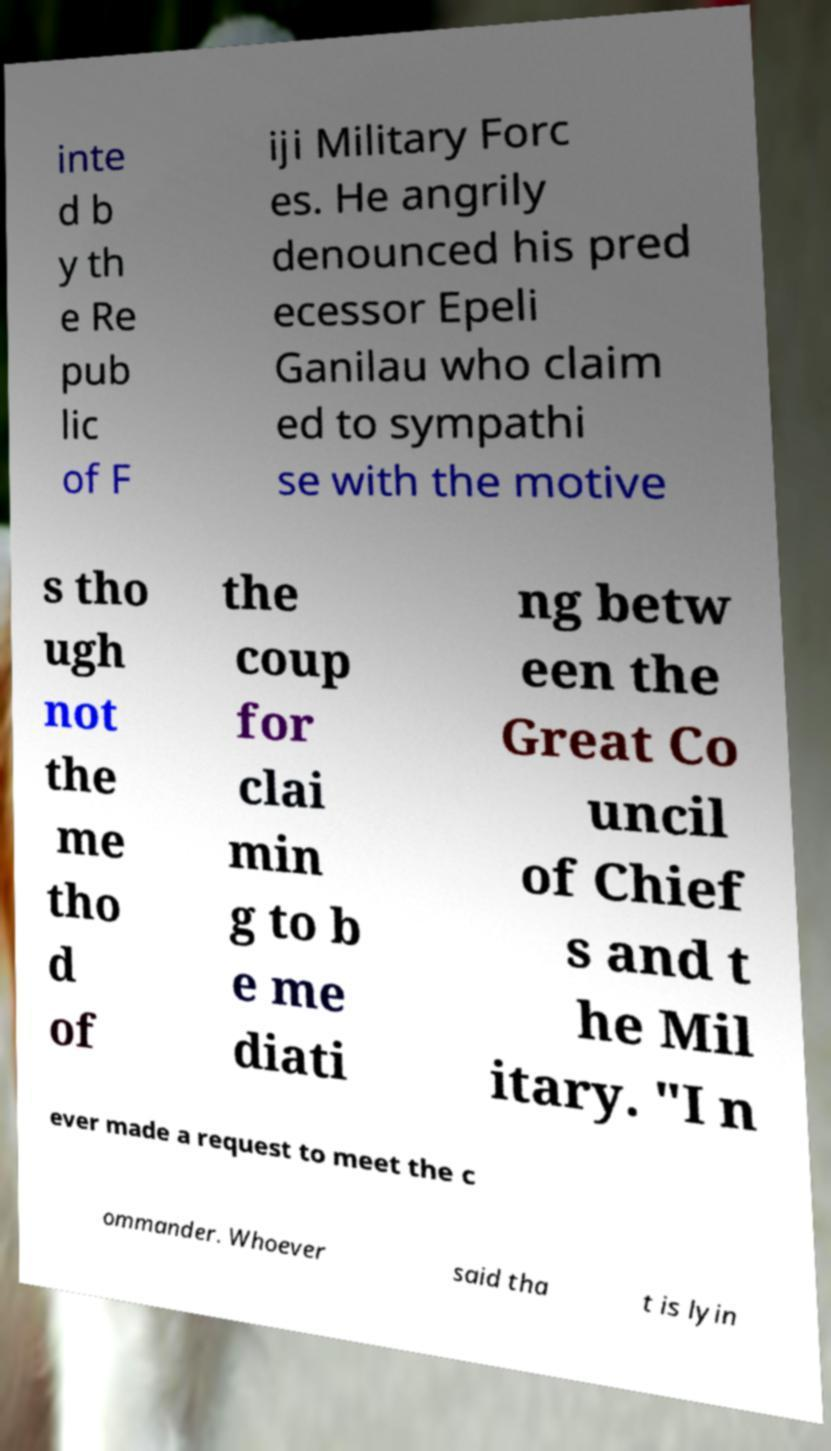Please identify and transcribe the text found in this image. inte d b y th e Re pub lic of F iji Military Forc es. He angrily denounced his pred ecessor Epeli Ganilau who claim ed to sympathi se with the motive s tho ugh not the me tho d of the coup for clai min g to b e me diati ng betw een the Great Co uncil of Chief s and t he Mil itary. "I n ever made a request to meet the c ommander. Whoever said tha t is lyin 